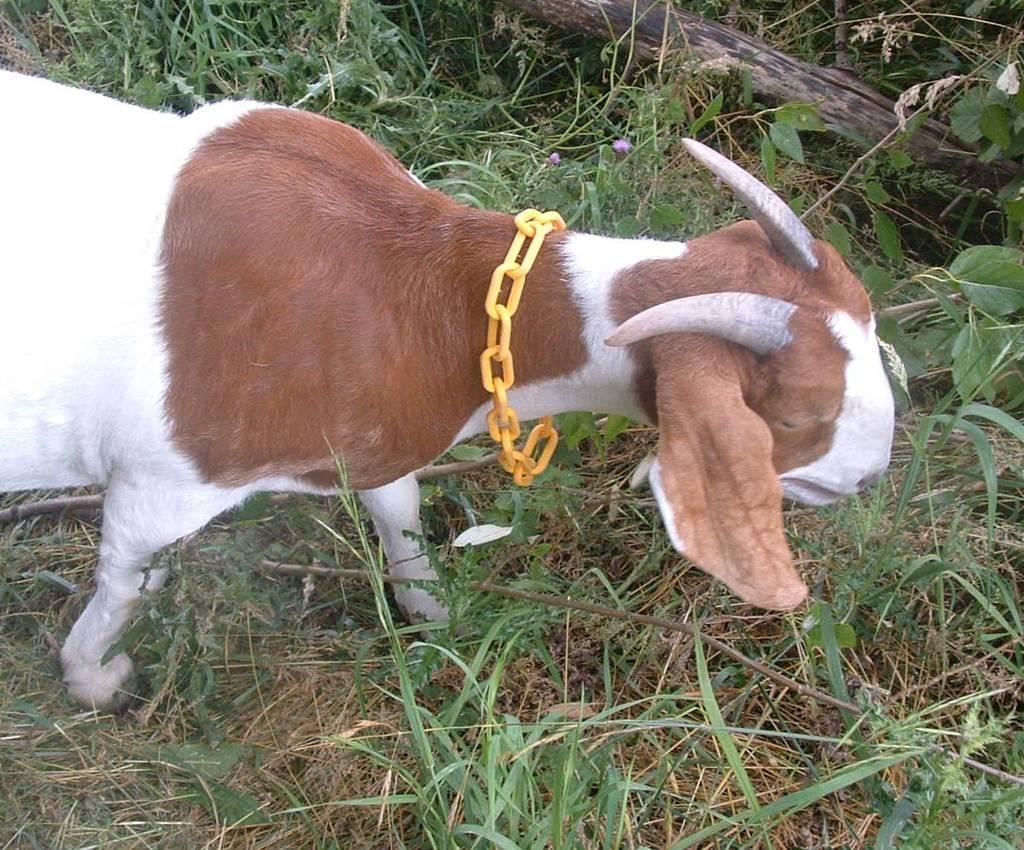Describe this image in one or two sentences. In this image, I can see a goat standing. This looks like an iron chain, which is yellow in color. I think this is the kind of a wooden pole. Here is the grass. 